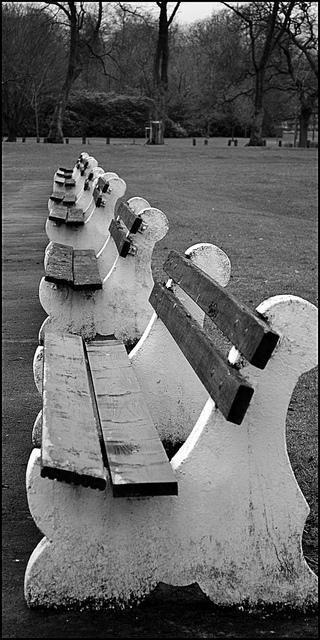How many benches have people sitting on them?
Give a very brief answer. 0. How many benches are in the photo?
Give a very brief answer. 3. 